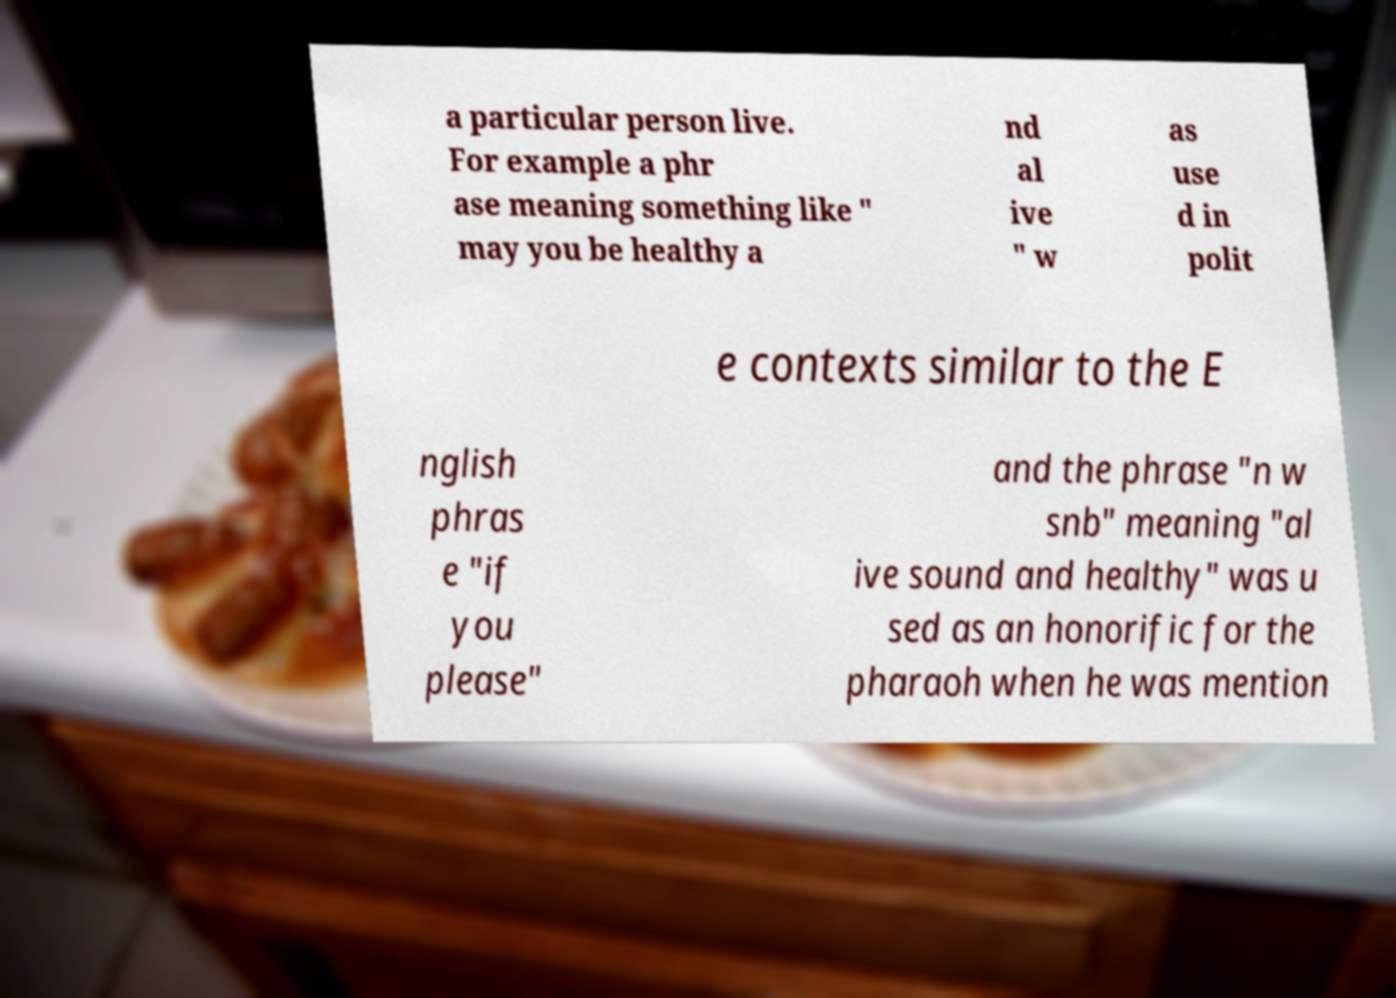Can you accurately transcribe the text from the provided image for me? a particular person live. For example a phr ase meaning something like " may you be healthy a nd al ive " w as use d in polit e contexts similar to the E nglish phras e "if you please" and the phrase "n w snb" meaning "al ive sound and healthy" was u sed as an honorific for the pharaoh when he was mention 